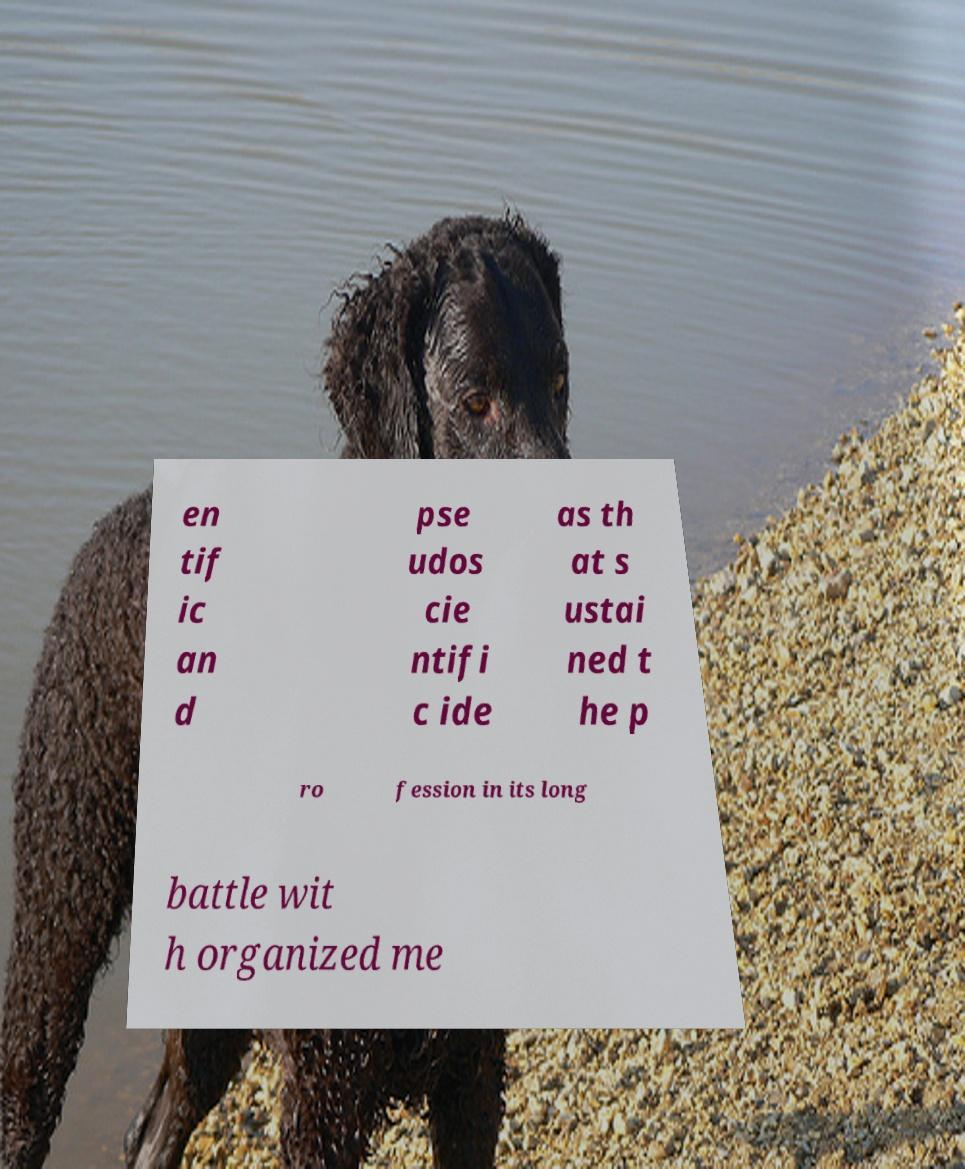Can you read and provide the text displayed in the image?This photo seems to have some interesting text. Can you extract and type it out for me? en tif ic an d pse udos cie ntifi c ide as th at s ustai ned t he p ro fession in its long battle wit h organized me 